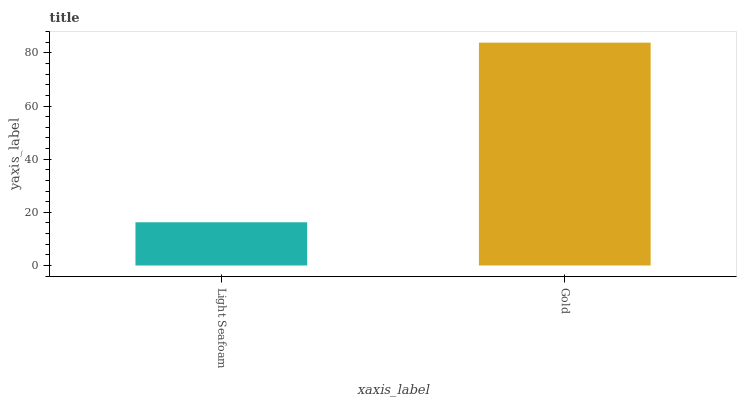Is Light Seafoam the minimum?
Answer yes or no. Yes. Is Gold the maximum?
Answer yes or no. Yes. Is Gold the minimum?
Answer yes or no. No. Is Gold greater than Light Seafoam?
Answer yes or no. Yes. Is Light Seafoam less than Gold?
Answer yes or no. Yes. Is Light Seafoam greater than Gold?
Answer yes or no. No. Is Gold less than Light Seafoam?
Answer yes or no. No. Is Gold the high median?
Answer yes or no. Yes. Is Light Seafoam the low median?
Answer yes or no. Yes. Is Light Seafoam the high median?
Answer yes or no. No. Is Gold the low median?
Answer yes or no. No. 